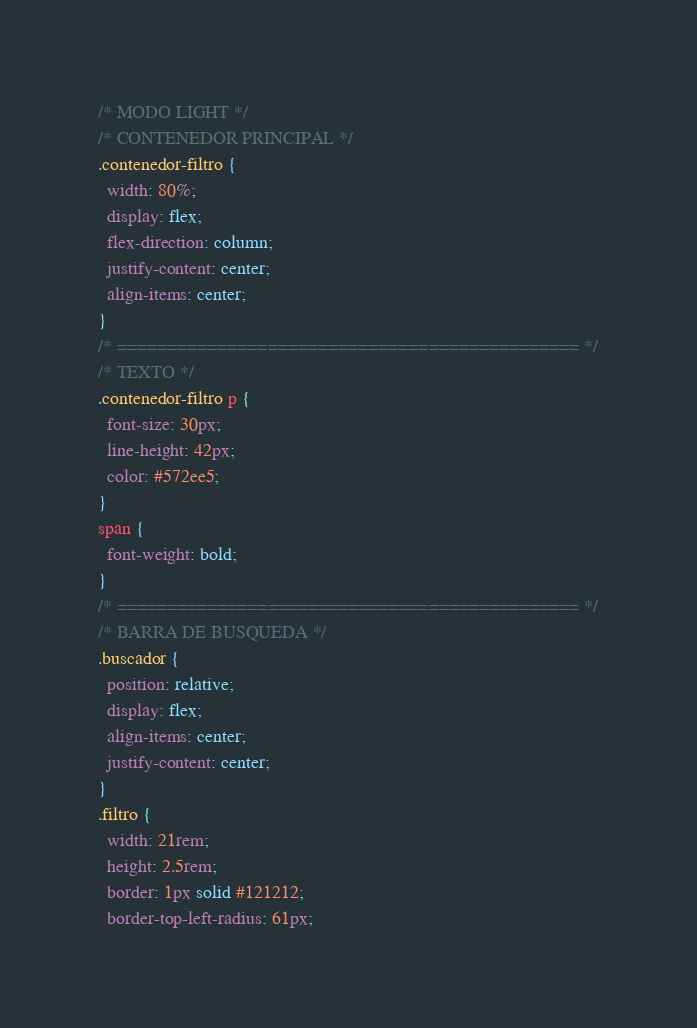Convert code to text. <code><loc_0><loc_0><loc_500><loc_500><_CSS_>/* MODO LIGHT */
/* CONTENEDOR PRINCIPAL */
.contenedor-filtro {
  width: 80%;
  display: flex;
  flex-direction: column;
  justify-content: center;
  align-items: center;
}
/* ============================================== */
/* TEXTO */
.contenedor-filtro p {
  font-size: 30px;
  line-height: 42px;
  color: #572ee5;
}
span {
  font-weight: bold;
}
/* ============================================== */
/* BARRA DE BUSQUEDA */
.buscador {
  position: relative;
  display: flex;
  align-items: center;
  justify-content: center;
}
.filtro {
  width: 21rem;
  height: 2.5rem;
  border: 1px solid #121212;
  border-top-left-radius: 61px;</code> 